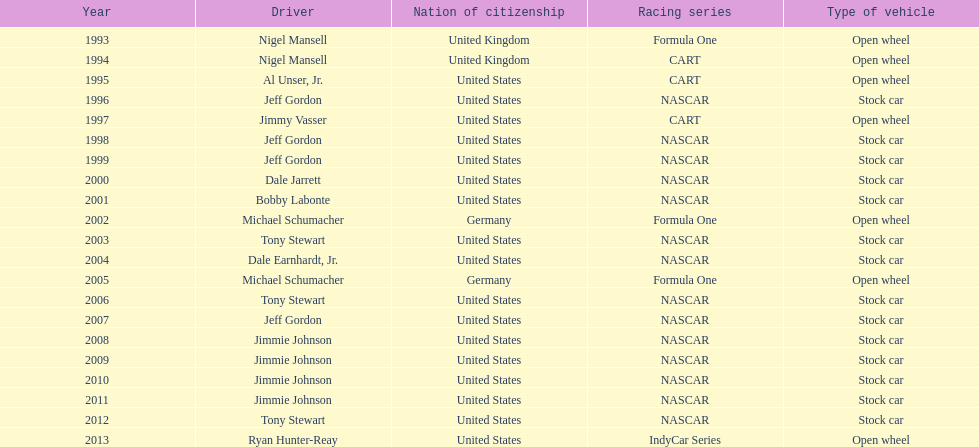In addition to nascar, from which other racing series have drivers won espy awards? Formula One, CART, IndyCar Series. Give me the full table as a dictionary. {'header': ['Year', 'Driver', 'Nation of citizenship', 'Racing series', 'Type of vehicle'], 'rows': [['1993', 'Nigel Mansell', 'United Kingdom', 'Formula One', 'Open wheel'], ['1994', 'Nigel Mansell', 'United Kingdom', 'CART', 'Open wheel'], ['1995', 'Al Unser, Jr.', 'United States', 'CART', 'Open wheel'], ['1996', 'Jeff Gordon', 'United States', 'NASCAR', 'Stock car'], ['1997', 'Jimmy Vasser', 'United States', 'CART', 'Open wheel'], ['1998', 'Jeff Gordon', 'United States', 'NASCAR', 'Stock car'], ['1999', 'Jeff Gordon', 'United States', 'NASCAR', 'Stock car'], ['2000', 'Dale Jarrett', 'United States', 'NASCAR', 'Stock car'], ['2001', 'Bobby Labonte', 'United States', 'NASCAR', 'Stock car'], ['2002', 'Michael Schumacher', 'Germany', 'Formula One', 'Open wheel'], ['2003', 'Tony Stewart', 'United States', 'NASCAR', 'Stock car'], ['2004', 'Dale Earnhardt, Jr.', 'United States', 'NASCAR', 'Stock car'], ['2005', 'Michael Schumacher', 'Germany', 'Formula One', 'Open wheel'], ['2006', 'Tony Stewart', 'United States', 'NASCAR', 'Stock car'], ['2007', 'Jeff Gordon', 'United States', 'NASCAR', 'Stock car'], ['2008', 'Jimmie Johnson', 'United States', 'NASCAR', 'Stock car'], ['2009', 'Jimmie Johnson', 'United States', 'NASCAR', 'Stock car'], ['2010', 'Jimmie Johnson', 'United States', 'NASCAR', 'Stock car'], ['2011', 'Jimmie Johnson', 'United States', 'NASCAR', 'Stock car'], ['2012', 'Tony Stewart', 'United States', 'NASCAR', 'Stock car'], ['2013', 'Ryan Hunter-Reay', 'United States', 'IndyCar Series', 'Open wheel']]} 